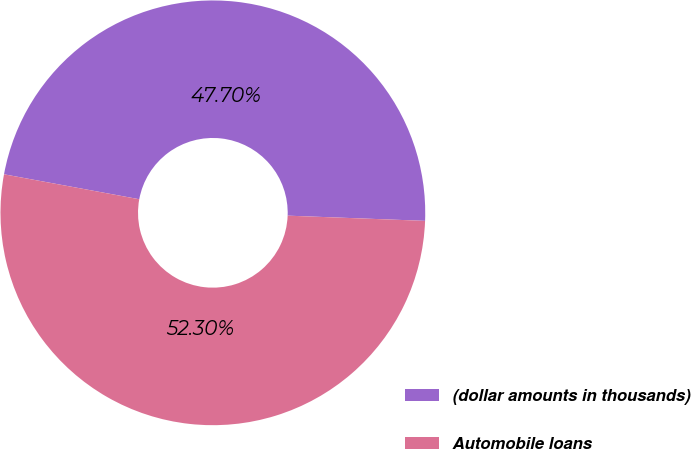Convert chart. <chart><loc_0><loc_0><loc_500><loc_500><pie_chart><fcel>(dollar amounts in thousands)<fcel>Automobile loans<nl><fcel>47.7%<fcel>52.3%<nl></chart> 